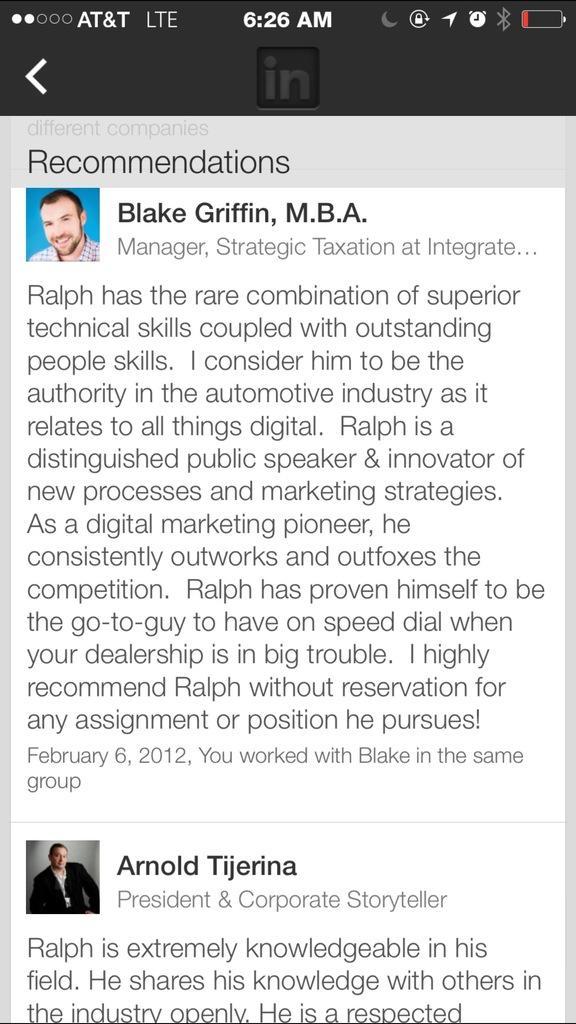Could you give a brief overview of what you see in this image? In this image I can see a screenshot of the mobile and I can see two persons faces and I can see something written on the screen. 